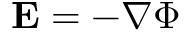<formula> <loc_0><loc_0><loc_500><loc_500>E = - \nabla \Phi</formula> 